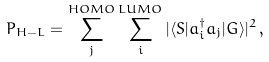Convert formula to latex. <formula><loc_0><loc_0><loc_500><loc_500>P _ { H - L } = \sum _ { j } ^ { H O M O } \sum _ { i } ^ { L U M O } | \langle S | a ^ { \dagger } _ { i } a _ { j } | G \rangle | ^ { 2 } \, ,</formula> 